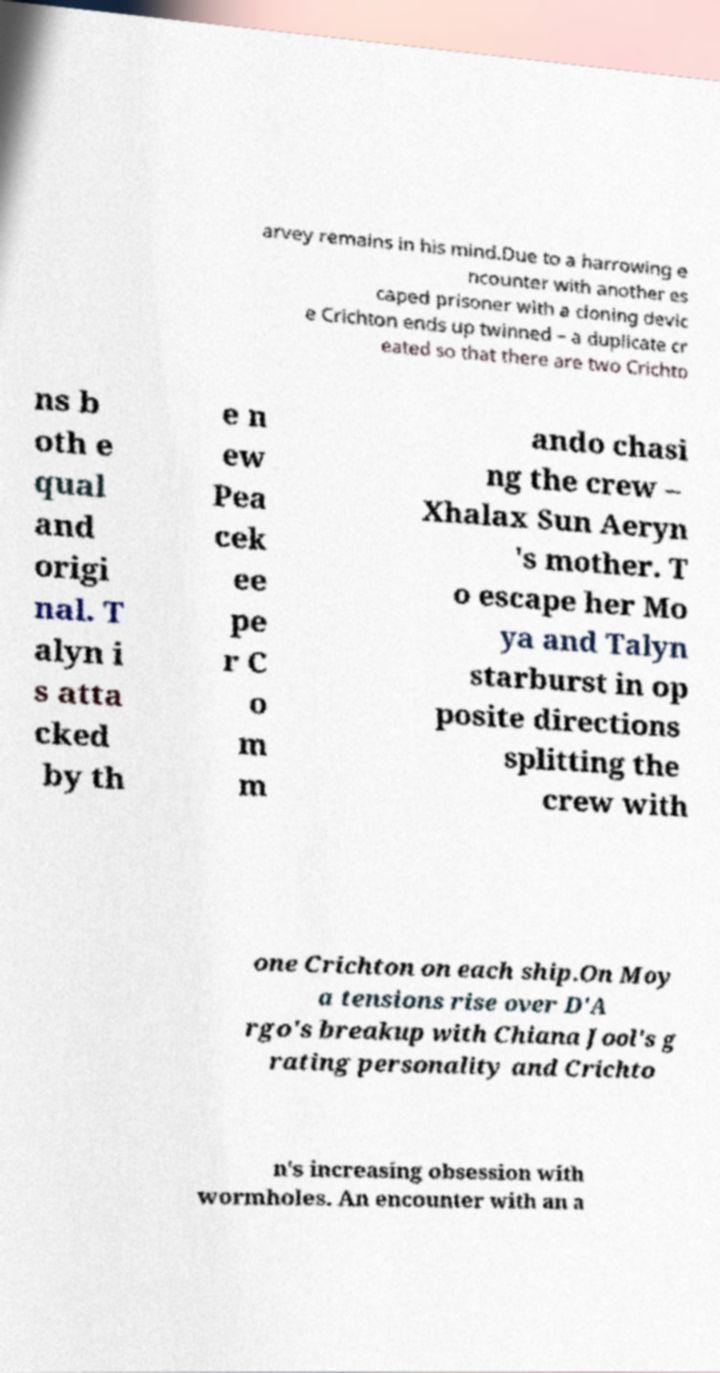Could you assist in decoding the text presented in this image and type it out clearly? arvey remains in his mind.Due to a harrowing e ncounter with another es caped prisoner with a cloning devic e Crichton ends up twinned – a duplicate cr eated so that there are two Crichto ns b oth e qual and origi nal. T alyn i s atta cked by th e n ew Pea cek ee pe r C o m m ando chasi ng the crew – Xhalax Sun Aeryn 's mother. T o escape her Mo ya and Talyn starburst in op posite directions splitting the crew with one Crichton on each ship.On Moy a tensions rise over D'A rgo's breakup with Chiana Jool's g rating personality and Crichto n's increasing obsession with wormholes. An encounter with an a 